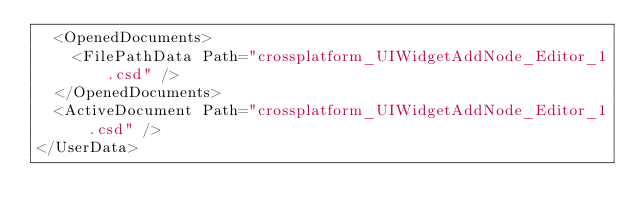<code> <loc_0><loc_0><loc_500><loc_500><_SQL_>  <OpenedDocuments>
    <FilePathData Path="crossplatform_UIWidgetAddNode_Editor_1.csd" />
  </OpenedDocuments>
  <ActiveDocument Path="crossplatform_UIWidgetAddNode_Editor_1.csd" />
</UserData></code> 